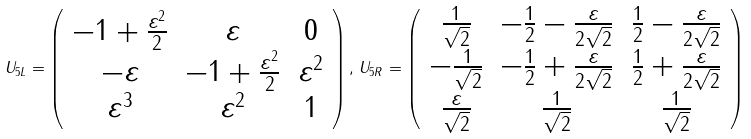Convert formula to latex. <formula><loc_0><loc_0><loc_500><loc_500>U _ { 5 L } = \left ( \begin{array} { c c c } - 1 + \frac { \varepsilon ^ { 2 } } { 2 } & \varepsilon & 0 \\ - \varepsilon & - 1 + \frac { \varepsilon ^ { 2 } } { 2 } & \varepsilon ^ { 2 } \\ \varepsilon ^ { 3 } & \varepsilon ^ { 2 } & 1 \\ \end{array} \right ) , \, U _ { 5 R } = \left ( \begin{array} { c c c } \frac { 1 } { \sqrt { 2 } } & - \frac { 1 } { 2 } - \frac { \varepsilon } { 2 \sqrt { 2 } } & \frac { 1 } { 2 } - \frac { \varepsilon } { 2 \sqrt { 2 } } \\ - \frac { 1 } { \sqrt { 2 } } & - \frac { 1 } { 2 } + \frac { \varepsilon } { 2 \sqrt { 2 } } & \frac { 1 } { 2 } + \frac { \varepsilon } { 2 \sqrt { 2 } } \\ \frac { \varepsilon } { \sqrt { 2 } } & \frac { 1 } { \sqrt { 2 } } & \frac { 1 } { \sqrt { 2 } } \\ \end{array} \right )</formula> 